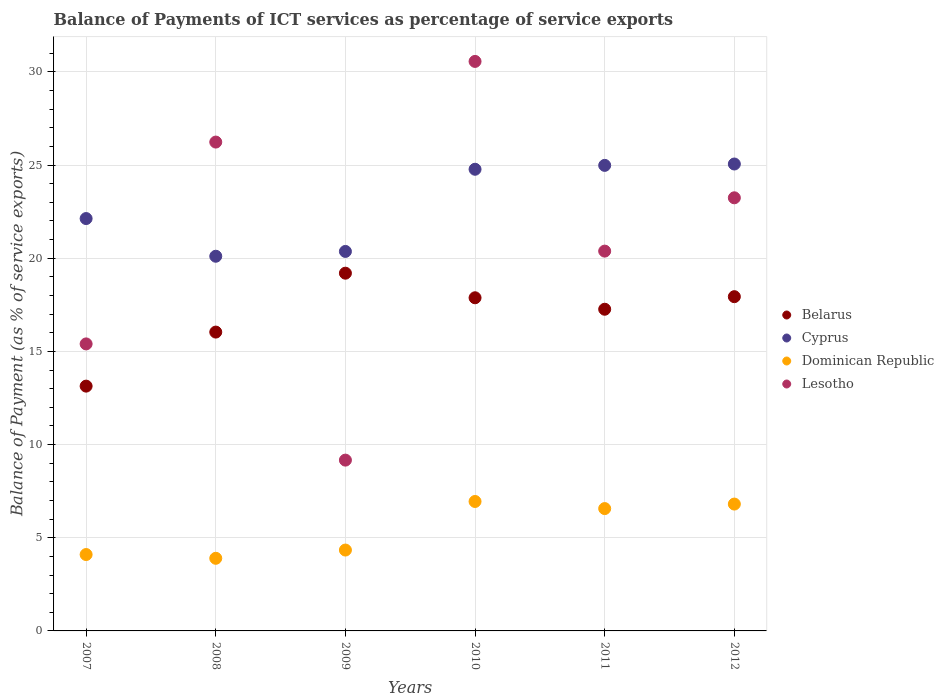How many different coloured dotlines are there?
Your answer should be compact. 4. Is the number of dotlines equal to the number of legend labels?
Offer a very short reply. Yes. What is the balance of payments of ICT services in Belarus in 2007?
Provide a succinct answer. 13.14. Across all years, what is the maximum balance of payments of ICT services in Lesotho?
Make the answer very short. 30.56. Across all years, what is the minimum balance of payments of ICT services in Cyprus?
Your response must be concise. 20.11. In which year was the balance of payments of ICT services in Lesotho maximum?
Offer a terse response. 2010. What is the total balance of payments of ICT services in Dominican Republic in the graph?
Keep it short and to the point. 32.66. What is the difference between the balance of payments of ICT services in Belarus in 2009 and that in 2010?
Keep it short and to the point. 1.32. What is the difference between the balance of payments of ICT services in Cyprus in 2007 and the balance of payments of ICT services in Dominican Republic in 2012?
Give a very brief answer. 15.32. What is the average balance of payments of ICT services in Belarus per year?
Give a very brief answer. 16.91. In the year 2010, what is the difference between the balance of payments of ICT services in Belarus and balance of payments of ICT services in Cyprus?
Ensure brevity in your answer.  -6.9. In how many years, is the balance of payments of ICT services in Lesotho greater than 7 %?
Your answer should be very brief. 6. What is the ratio of the balance of payments of ICT services in Belarus in 2010 to that in 2012?
Give a very brief answer. 1. Is the balance of payments of ICT services in Belarus in 2007 less than that in 2010?
Your response must be concise. Yes. What is the difference between the highest and the second highest balance of payments of ICT services in Cyprus?
Provide a short and direct response. 0.07. What is the difference between the highest and the lowest balance of payments of ICT services in Belarus?
Ensure brevity in your answer.  6.06. In how many years, is the balance of payments of ICT services in Lesotho greater than the average balance of payments of ICT services in Lesotho taken over all years?
Your response must be concise. 3. Is it the case that in every year, the sum of the balance of payments of ICT services in Belarus and balance of payments of ICT services in Cyprus  is greater than the sum of balance of payments of ICT services in Dominican Republic and balance of payments of ICT services in Lesotho?
Offer a very short reply. No. Does the balance of payments of ICT services in Cyprus monotonically increase over the years?
Give a very brief answer. No. How many years are there in the graph?
Your response must be concise. 6. Does the graph contain grids?
Provide a short and direct response. Yes. What is the title of the graph?
Keep it short and to the point. Balance of Payments of ICT services as percentage of service exports. What is the label or title of the Y-axis?
Your response must be concise. Balance of Payment (as % of service exports). What is the Balance of Payment (as % of service exports) in Belarus in 2007?
Make the answer very short. 13.14. What is the Balance of Payment (as % of service exports) of Cyprus in 2007?
Make the answer very short. 22.13. What is the Balance of Payment (as % of service exports) of Dominican Republic in 2007?
Give a very brief answer. 4.1. What is the Balance of Payment (as % of service exports) in Lesotho in 2007?
Offer a very short reply. 15.4. What is the Balance of Payment (as % of service exports) of Belarus in 2008?
Your answer should be very brief. 16.04. What is the Balance of Payment (as % of service exports) of Cyprus in 2008?
Keep it short and to the point. 20.11. What is the Balance of Payment (as % of service exports) in Dominican Republic in 2008?
Offer a terse response. 3.9. What is the Balance of Payment (as % of service exports) in Lesotho in 2008?
Your answer should be very brief. 26.24. What is the Balance of Payment (as % of service exports) in Belarus in 2009?
Your answer should be compact. 19.2. What is the Balance of Payment (as % of service exports) of Cyprus in 2009?
Offer a very short reply. 20.37. What is the Balance of Payment (as % of service exports) in Dominican Republic in 2009?
Give a very brief answer. 4.34. What is the Balance of Payment (as % of service exports) in Lesotho in 2009?
Offer a very short reply. 9.17. What is the Balance of Payment (as % of service exports) in Belarus in 2010?
Your answer should be compact. 17.88. What is the Balance of Payment (as % of service exports) in Cyprus in 2010?
Keep it short and to the point. 24.78. What is the Balance of Payment (as % of service exports) in Dominican Republic in 2010?
Offer a very short reply. 6.95. What is the Balance of Payment (as % of service exports) of Lesotho in 2010?
Your answer should be very brief. 30.56. What is the Balance of Payment (as % of service exports) in Belarus in 2011?
Offer a very short reply. 17.26. What is the Balance of Payment (as % of service exports) of Cyprus in 2011?
Your answer should be very brief. 24.98. What is the Balance of Payment (as % of service exports) in Dominican Republic in 2011?
Make the answer very short. 6.57. What is the Balance of Payment (as % of service exports) of Lesotho in 2011?
Give a very brief answer. 20.38. What is the Balance of Payment (as % of service exports) of Belarus in 2012?
Provide a short and direct response. 17.94. What is the Balance of Payment (as % of service exports) in Cyprus in 2012?
Offer a terse response. 25.06. What is the Balance of Payment (as % of service exports) of Dominican Republic in 2012?
Your answer should be very brief. 6.81. What is the Balance of Payment (as % of service exports) of Lesotho in 2012?
Ensure brevity in your answer.  23.24. Across all years, what is the maximum Balance of Payment (as % of service exports) in Belarus?
Your answer should be very brief. 19.2. Across all years, what is the maximum Balance of Payment (as % of service exports) in Cyprus?
Give a very brief answer. 25.06. Across all years, what is the maximum Balance of Payment (as % of service exports) of Dominican Republic?
Offer a very short reply. 6.95. Across all years, what is the maximum Balance of Payment (as % of service exports) in Lesotho?
Make the answer very short. 30.56. Across all years, what is the minimum Balance of Payment (as % of service exports) of Belarus?
Your response must be concise. 13.14. Across all years, what is the minimum Balance of Payment (as % of service exports) in Cyprus?
Keep it short and to the point. 20.11. Across all years, what is the minimum Balance of Payment (as % of service exports) in Dominican Republic?
Your response must be concise. 3.9. Across all years, what is the minimum Balance of Payment (as % of service exports) of Lesotho?
Keep it short and to the point. 9.17. What is the total Balance of Payment (as % of service exports) in Belarus in the graph?
Keep it short and to the point. 101.45. What is the total Balance of Payment (as % of service exports) in Cyprus in the graph?
Make the answer very short. 137.42. What is the total Balance of Payment (as % of service exports) in Dominican Republic in the graph?
Your answer should be compact. 32.66. What is the total Balance of Payment (as % of service exports) of Lesotho in the graph?
Make the answer very short. 124.99. What is the difference between the Balance of Payment (as % of service exports) in Belarus in 2007 and that in 2008?
Your response must be concise. -2.9. What is the difference between the Balance of Payment (as % of service exports) in Cyprus in 2007 and that in 2008?
Ensure brevity in your answer.  2.02. What is the difference between the Balance of Payment (as % of service exports) of Dominican Republic in 2007 and that in 2008?
Give a very brief answer. 0.2. What is the difference between the Balance of Payment (as % of service exports) of Lesotho in 2007 and that in 2008?
Your answer should be compact. -10.83. What is the difference between the Balance of Payment (as % of service exports) in Belarus in 2007 and that in 2009?
Provide a succinct answer. -6.06. What is the difference between the Balance of Payment (as % of service exports) of Cyprus in 2007 and that in 2009?
Offer a terse response. 1.76. What is the difference between the Balance of Payment (as % of service exports) of Dominican Republic in 2007 and that in 2009?
Keep it short and to the point. -0.24. What is the difference between the Balance of Payment (as % of service exports) of Lesotho in 2007 and that in 2009?
Provide a short and direct response. 6.24. What is the difference between the Balance of Payment (as % of service exports) of Belarus in 2007 and that in 2010?
Give a very brief answer. -4.74. What is the difference between the Balance of Payment (as % of service exports) of Cyprus in 2007 and that in 2010?
Provide a succinct answer. -2.65. What is the difference between the Balance of Payment (as % of service exports) of Dominican Republic in 2007 and that in 2010?
Ensure brevity in your answer.  -2.85. What is the difference between the Balance of Payment (as % of service exports) in Lesotho in 2007 and that in 2010?
Ensure brevity in your answer.  -15.16. What is the difference between the Balance of Payment (as % of service exports) in Belarus in 2007 and that in 2011?
Give a very brief answer. -4.13. What is the difference between the Balance of Payment (as % of service exports) of Cyprus in 2007 and that in 2011?
Give a very brief answer. -2.85. What is the difference between the Balance of Payment (as % of service exports) in Dominican Republic in 2007 and that in 2011?
Offer a terse response. -2.47. What is the difference between the Balance of Payment (as % of service exports) of Lesotho in 2007 and that in 2011?
Your response must be concise. -4.98. What is the difference between the Balance of Payment (as % of service exports) of Belarus in 2007 and that in 2012?
Ensure brevity in your answer.  -4.8. What is the difference between the Balance of Payment (as % of service exports) of Cyprus in 2007 and that in 2012?
Your response must be concise. -2.93. What is the difference between the Balance of Payment (as % of service exports) of Dominican Republic in 2007 and that in 2012?
Offer a very short reply. -2.71. What is the difference between the Balance of Payment (as % of service exports) in Lesotho in 2007 and that in 2012?
Your response must be concise. -7.84. What is the difference between the Balance of Payment (as % of service exports) in Belarus in 2008 and that in 2009?
Give a very brief answer. -3.16. What is the difference between the Balance of Payment (as % of service exports) of Cyprus in 2008 and that in 2009?
Your answer should be compact. -0.26. What is the difference between the Balance of Payment (as % of service exports) in Dominican Republic in 2008 and that in 2009?
Make the answer very short. -0.44. What is the difference between the Balance of Payment (as % of service exports) of Lesotho in 2008 and that in 2009?
Provide a short and direct response. 17.07. What is the difference between the Balance of Payment (as % of service exports) in Belarus in 2008 and that in 2010?
Provide a succinct answer. -1.84. What is the difference between the Balance of Payment (as % of service exports) in Cyprus in 2008 and that in 2010?
Your answer should be very brief. -4.67. What is the difference between the Balance of Payment (as % of service exports) of Dominican Republic in 2008 and that in 2010?
Give a very brief answer. -3.05. What is the difference between the Balance of Payment (as % of service exports) of Lesotho in 2008 and that in 2010?
Ensure brevity in your answer.  -4.33. What is the difference between the Balance of Payment (as % of service exports) in Belarus in 2008 and that in 2011?
Provide a short and direct response. -1.23. What is the difference between the Balance of Payment (as % of service exports) of Cyprus in 2008 and that in 2011?
Your answer should be compact. -4.88. What is the difference between the Balance of Payment (as % of service exports) in Dominican Republic in 2008 and that in 2011?
Offer a very short reply. -2.67. What is the difference between the Balance of Payment (as % of service exports) of Lesotho in 2008 and that in 2011?
Keep it short and to the point. 5.85. What is the difference between the Balance of Payment (as % of service exports) of Belarus in 2008 and that in 2012?
Make the answer very short. -1.9. What is the difference between the Balance of Payment (as % of service exports) in Cyprus in 2008 and that in 2012?
Make the answer very short. -4.95. What is the difference between the Balance of Payment (as % of service exports) of Dominican Republic in 2008 and that in 2012?
Provide a succinct answer. -2.91. What is the difference between the Balance of Payment (as % of service exports) of Lesotho in 2008 and that in 2012?
Offer a terse response. 2.99. What is the difference between the Balance of Payment (as % of service exports) in Belarus in 2009 and that in 2010?
Keep it short and to the point. 1.32. What is the difference between the Balance of Payment (as % of service exports) of Cyprus in 2009 and that in 2010?
Offer a very short reply. -4.41. What is the difference between the Balance of Payment (as % of service exports) of Dominican Republic in 2009 and that in 2010?
Offer a terse response. -2.61. What is the difference between the Balance of Payment (as % of service exports) of Lesotho in 2009 and that in 2010?
Make the answer very short. -21.4. What is the difference between the Balance of Payment (as % of service exports) in Belarus in 2009 and that in 2011?
Offer a terse response. 1.93. What is the difference between the Balance of Payment (as % of service exports) in Cyprus in 2009 and that in 2011?
Offer a very short reply. -4.62. What is the difference between the Balance of Payment (as % of service exports) of Dominican Republic in 2009 and that in 2011?
Keep it short and to the point. -2.23. What is the difference between the Balance of Payment (as % of service exports) of Lesotho in 2009 and that in 2011?
Offer a terse response. -11.22. What is the difference between the Balance of Payment (as % of service exports) of Belarus in 2009 and that in 2012?
Ensure brevity in your answer.  1.26. What is the difference between the Balance of Payment (as % of service exports) in Cyprus in 2009 and that in 2012?
Make the answer very short. -4.69. What is the difference between the Balance of Payment (as % of service exports) in Dominican Republic in 2009 and that in 2012?
Ensure brevity in your answer.  -2.47. What is the difference between the Balance of Payment (as % of service exports) of Lesotho in 2009 and that in 2012?
Offer a terse response. -14.08. What is the difference between the Balance of Payment (as % of service exports) in Belarus in 2010 and that in 2011?
Provide a short and direct response. 0.62. What is the difference between the Balance of Payment (as % of service exports) in Cyprus in 2010 and that in 2011?
Your answer should be compact. -0.21. What is the difference between the Balance of Payment (as % of service exports) of Dominican Republic in 2010 and that in 2011?
Make the answer very short. 0.38. What is the difference between the Balance of Payment (as % of service exports) in Lesotho in 2010 and that in 2011?
Your answer should be very brief. 10.18. What is the difference between the Balance of Payment (as % of service exports) in Belarus in 2010 and that in 2012?
Your response must be concise. -0.06. What is the difference between the Balance of Payment (as % of service exports) of Cyprus in 2010 and that in 2012?
Keep it short and to the point. -0.28. What is the difference between the Balance of Payment (as % of service exports) in Dominican Republic in 2010 and that in 2012?
Your response must be concise. 0.14. What is the difference between the Balance of Payment (as % of service exports) in Lesotho in 2010 and that in 2012?
Offer a terse response. 7.32. What is the difference between the Balance of Payment (as % of service exports) of Belarus in 2011 and that in 2012?
Your answer should be very brief. -0.67. What is the difference between the Balance of Payment (as % of service exports) of Cyprus in 2011 and that in 2012?
Your response must be concise. -0.07. What is the difference between the Balance of Payment (as % of service exports) of Dominican Republic in 2011 and that in 2012?
Your answer should be compact. -0.24. What is the difference between the Balance of Payment (as % of service exports) in Lesotho in 2011 and that in 2012?
Ensure brevity in your answer.  -2.86. What is the difference between the Balance of Payment (as % of service exports) of Belarus in 2007 and the Balance of Payment (as % of service exports) of Cyprus in 2008?
Keep it short and to the point. -6.97. What is the difference between the Balance of Payment (as % of service exports) of Belarus in 2007 and the Balance of Payment (as % of service exports) of Dominican Republic in 2008?
Offer a terse response. 9.24. What is the difference between the Balance of Payment (as % of service exports) in Belarus in 2007 and the Balance of Payment (as % of service exports) in Lesotho in 2008?
Ensure brevity in your answer.  -13.1. What is the difference between the Balance of Payment (as % of service exports) of Cyprus in 2007 and the Balance of Payment (as % of service exports) of Dominican Republic in 2008?
Provide a short and direct response. 18.23. What is the difference between the Balance of Payment (as % of service exports) of Cyprus in 2007 and the Balance of Payment (as % of service exports) of Lesotho in 2008?
Give a very brief answer. -4.1. What is the difference between the Balance of Payment (as % of service exports) of Dominican Republic in 2007 and the Balance of Payment (as % of service exports) of Lesotho in 2008?
Keep it short and to the point. -22.14. What is the difference between the Balance of Payment (as % of service exports) of Belarus in 2007 and the Balance of Payment (as % of service exports) of Cyprus in 2009?
Provide a succinct answer. -7.23. What is the difference between the Balance of Payment (as % of service exports) in Belarus in 2007 and the Balance of Payment (as % of service exports) in Dominican Republic in 2009?
Give a very brief answer. 8.8. What is the difference between the Balance of Payment (as % of service exports) of Belarus in 2007 and the Balance of Payment (as % of service exports) of Lesotho in 2009?
Provide a short and direct response. 3.97. What is the difference between the Balance of Payment (as % of service exports) in Cyprus in 2007 and the Balance of Payment (as % of service exports) in Dominican Republic in 2009?
Your answer should be very brief. 17.79. What is the difference between the Balance of Payment (as % of service exports) in Cyprus in 2007 and the Balance of Payment (as % of service exports) in Lesotho in 2009?
Make the answer very short. 12.96. What is the difference between the Balance of Payment (as % of service exports) in Dominican Republic in 2007 and the Balance of Payment (as % of service exports) in Lesotho in 2009?
Ensure brevity in your answer.  -5.07. What is the difference between the Balance of Payment (as % of service exports) in Belarus in 2007 and the Balance of Payment (as % of service exports) in Cyprus in 2010?
Your response must be concise. -11.64. What is the difference between the Balance of Payment (as % of service exports) in Belarus in 2007 and the Balance of Payment (as % of service exports) in Dominican Republic in 2010?
Your response must be concise. 6.19. What is the difference between the Balance of Payment (as % of service exports) of Belarus in 2007 and the Balance of Payment (as % of service exports) of Lesotho in 2010?
Keep it short and to the point. -17.43. What is the difference between the Balance of Payment (as % of service exports) in Cyprus in 2007 and the Balance of Payment (as % of service exports) in Dominican Republic in 2010?
Your answer should be very brief. 15.18. What is the difference between the Balance of Payment (as % of service exports) in Cyprus in 2007 and the Balance of Payment (as % of service exports) in Lesotho in 2010?
Provide a succinct answer. -8.43. What is the difference between the Balance of Payment (as % of service exports) of Dominican Republic in 2007 and the Balance of Payment (as % of service exports) of Lesotho in 2010?
Give a very brief answer. -26.46. What is the difference between the Balance of Payment (as % of service exports) in Belarus in 2007 and the Balance of Payment (as % of service exports) in Cyprus in 2011?
Your answer should be very brief. -11.85. What is the difference between the Balance of Payment (as % of service exports) of Belarus in 2007 and the Balance of Payment (as % of service exports) of Dominican Republic in 2011?
Your answer should be compact. 6.57. What is the difference between the Balance of Payment (as % of service exports) of Belarus in 2007 and the Balance of Payment (as % of service exports) of Lesotho in 2011?
Your answer should be compact. -7.25. What is the difference between the Balance of Payment (as % of service exports) of Cyprus in 2007 and the Balance of Payment (as % of service exports) of Dominican Republic in 2011?
Ensure brevity in your answer.  15.56. What is the difference between the Balance of Payment (as % of service exports) of Cyprus in 2007 and the Balance of Payment (as % of service exports) of Lesotho in 2011?
Offer a terse response. 1.75. What is the difference between the Balance of Payment (as % of service exports) of Dominican Republic in 2007 and the Balance of Payment (as % of service exports) of Lesotho in 2011?
Your answer should be very brief. -16.28. What is the difference between the Balance of Payment (as % of service exports) of Belarus in 2007 and the Balance of Payment (as % of service exports) of Cyprus in 2012?
Your response must be concise. -11.92. What is the difference between the Balance of Payment (as % of service exports) in Belarus in 2007 and the Balance of Payment (as % of service exports) in Dominican Republic in 2012?
Your answer should be compact. 6.33. What is the difference between the Balance of Payment (as % of service exports) in Belarus in 2007 and the Balance of Payment (as % of service exports) in Lesotho in 2012?
Offer a terse response. -10.11. What is the difference between the Balance of Payment (as % of service exports) in Cyprus in 2007 and the Balance of Payment (as % of service exports) in Dominican Republic in 2012?
Provide a short and direct response. 15.32. What is the difference between the Balance of Payment (as % of service exports) of Cyprus in 2007 and the Balance of Payment (as % of service exports) of Lesotho in 2012?
Your response must be concise. -1.11. What is the difference between the Balance of Payment (as % of service exports) in Dominican Republic in 2007 and the Balance of Payment (as % of service exports) in Lesotho in 2012?
Your response must be concise. -19.14. What is the difference between the Balance of Payment (as % of service exports) in Belarus in 2008 and the Balance of Payment (as % of service exports) in Cyprus in 2009?
Your answer should be compact. -4.33. What is the difference between the Balance of Payment (as % of service exports) of Belarus in 2008 and the Balance of Payment (as % of service exports) of Dominican Republic in 2009?
Offer a terse response. 11.7. What is the difference between the Balance of Payment (as % of service exports) of Belarus in 2008 and the Balance of Payment (as % of service exports) of Lesotho in 2009?
Make the answer very short. 6.87. What is the difference between the Balance of Payment (as % of service exports) of Cyprus in 2008 and the Balance of Payment (as % of service exports) of Dominican Republic in 2009?
Your answer should be compact. 15.77. What is the difference between the Balance of Payment (as % of service exports) in Cyprus in 2008 and the Balance of Payment (as % of service exports) in Lesotho in 2009?
Your answer should be very brief. 10.94. What is the difference between the Balance of Payment (as % of service exports) in Dominican Republic in 2008 and the Balance of Payment (as % of service exports) in Lesotho in 2009?
Make the answer very short. -5.27. What is the difference between the Balance of Payment (as % of service exports) in Belarus in 2008 and the Balance of Payment (as % of service exports) in Cyprus in 2010?
Give a very brief answer. -8.74. What is the difference between the Balance of Payment (as % of service exports) in Belarus in 2008 and the Balance of Payment (as % of service exports) in Dominican Republic in 2010?
Offer a very short reply. 9.09. What is the difference between the Balance of Payment (as % of service exports) of Belarus in 2008 and the Balance of Payment (as % of service exports) of Lesotho in 2010?
Your answer should be very brief. -14.53. What is the difference between the Balance of Payment (as % of service exports) in Cyprus in 2008 and the Balance of Payment (as % of service exports) in Dominican Republic in 2010?
Your answer should be very brief. 13.16. What is the difference between the Balance of Payment (as % of service exports) in Cyprus in 2008 and the Balance of Payment (as % of service exports) in Lesotho in 2010?
Offer a very short reply. -10.46. What is the difference between the Balance of Payment (as % of service exports) in Dominican Republic in 2008 and the Balance of Payment (as % of service exports) in Lesotho in 2010?
Your answer should be very brief. -26.67. What is the difference between the Balance of Payment (as % of service exports) of Belarus in 2008 and the Balance of Payment (as % of service exports) of Cyprus in 2011?
Offer a terse response. -8.95. What is the difference between the Balance of Payment (as % of service exports) in Belarus in 2008 and the Balance of Payment (as % of service exports) in Dominican Republic in 2011?
Your answer should be compact. 9.47. What is the difference between the Balance of Payment (as % of service exports) in Belarus in 2008 and the Balance of Payment (as % of service exports) in Lesotho in 2011?
Your response must be concise. -4.35. What is the difference between the Balance of Payment (as % of service exports) in Cyprus in 2008 and the Balance of Payment (as % of service exports) in Dominican Republic in 2011?
Your response must be concise. 13.54. What is the difference between the Balance of Payment (as % of service exports) in Cyprus in 2008 and the Balance of Payment (as % of service exports) in Lesotho in 2011?
Your response must be concise. -0.28. What is the difference between the Balance of Payment (as % of service exports) of Dominican Republic in 2008 and the Balance of Payment (as % of service exports) of Lesotho in 2011?
Offer a terse response. -16.49. What is the difference between the Balance of Payment (as % of service exports) of Belarus in 2008 and the Balance of Payment (as % of service exports) of Cyprus in 2012?
Make the answer very short. -9.02. What is the difference between the Balance of Payment (as % of service exports) in Belarus in 2008 and the Balance of Payment (as % of service exports) in Dominican Republic in 2012?
Make the answer very short. 9.23. What is the difference between the Balance of Payment (as % of service exports) in Belarus in 2008 and the Balance of Payment (as % of service exports) in Lesotho in 2012?
Make the answer very short. -7.21. What is the difference between the Balance of Payment (as % of service exports) in Cyprus in 2008 and the Balance of Payment (as % of service exports) in Lesotho in 2012?
Keep it short and to the point. -3.14. What is the difference between the Balance of Payment (as % of service exports) in Dominican Republic in 2008 and the Balance of Payment (as % of service exports) in Lesotho in 2012?
Keep it short and to the point. -19.35. What is the difference between the Balance of Payment (as % of service exports) in Belarus in 2009 and the Balance of Payment (as % of service exports) in Cyprus in 2010?
Provide a short and direct response. -5.58. What is the difference between the Balance of Payment (as % of service exports) in Belarus in 2009 and the Balance of Payment (as % of service exports) in Dominican Republic in 2010?
Keep it short and to the point. 12.25. What is the difference between the Balance of Payment (as % of service exports) of Belarus in 2009 and the Balance of Payment (as % of service exports) of Lesotho in 2010?
Your response must be concise. -11.37. What is the difference between the Balance of Payment (as % of service exports) of Cyprus in 2009 and the Balance of Payment (as % of service exports) of Dominican Republic in 2010?
Provide a short and direct response. 13.42. What is the difference between the Balance of Payment (as % of service exports) of Cyprus in 2009 and the Balance of Payment (as % of service exports) of Lesotho in 2010?
Keep it short and to the point. -10.2. What is the difference between the Balance of Payment (as % of service exports) in Dominican Republic in 2009 and the Balance of Payment (as % of service exports) in Lesotho in 2010?
Ensure brevity in your answer.  -26.22. What is the difference between the Balance of Payment (as % of service exports) of Belarus in 2009 and the Balance of Payment (as % of service exports) of Cyprus in 2011?
Your answer should be very brief. -5.79. What is the difference between the Balance of Payment (as % of service exports) of Belarus in 2009 and the Balance of Payment (as % of service exports) of Dominican Republic in 2011?
Your answer should be very brief. 12.63. What is the difference between the Balance of Payment (as % of service exports) of Belarus in 2009 and the Balance of Payment (as % of service exports) of Lesotho in 2011?
Keep it short and to the point. -1.18. What is the difference between the Balance of Payment (as % of service exports) in Cyprus in 2009 and the Balance of Payment (as % of service exports) in Dominican Republic in 2011?
Give a very brief answer. 13.8. What is the difference between the Balance of Payment (as % of service exports) in Cyprus in 2009 and the Balance of Payment (as % of service exports) in Lesotho in 2011?
Your response must be concise. -0.02. What is the difference between the Balance of Payment (as % of service exports) in Dominican Republic in 2009 and the Balance of Payment (as % of service exports) in Lesotho in 2011?
Your answer should be compact. -16.04. What is the difference between the Balance of Payment (as % of service exports) of Belarus in 2009 and the Balance of Payment (as % of service exports) of Cyprus in 2012?
Keep it short and to the point. -5.86. What is the difference between the Balance of Payment (as % of service exports) in Belarus in 2009 and the Balance of Payment (as % of service exports) in Dominican Republic in 2012?
Make the answer very short. 12.39. What is the difference between the Balance of Payment (as % of service exports) of Belarus in 2009 and the Balance of Payment (as % of service exports) of Lesotho in 2012?
Your answer should be compact. -4.05. What is the difference between the Balance of Payment (as % of service exports) of Cyprus in 2009 and the Balance of Payment (as % of service exports) of Dominican Republic in 2012?
Your response must be concise. 13.56. What is the difference between the Balance of Payment (as % of service exports) of Cyprus in 2009 and the Balance of Payment (as % of service exports) of Lesotho in 2012?
Give a very brief answer. -2.88. What is the difference between the Balance of Payment (as % of service exports) in Dominican Republic in 2009 and the Balance of Payment (as % of service exports) in Lesotho in 2012?
Make the answer very short. -18.9. What is the difference between the Balance of Payment (as % of service exports) of Belarus in 2010 and the Balance of Payment (as % of service exports) of Cyprus in 2011?
Provide a succinct answer. -7.11. What is the difference between the Balance of Payment (as % of service exports) in Belarus in 2010 and the Balance of Payment (as % of service exports) in Dominican Republic in 2011?
Your answer should be compact. 11.31. What is the difference between the Balance of Payment (as % of service exports) of Belarus in 2010 and the Balance of Payment (as % of service exports) of Lesotho in 2011?
Provide a succinct answer. -2.5. What is the difference between the Balance of Payment (as % of service exports) in Cyprus in 2010 and the Balance of Payment (as % of service exports) in Dominican Republic in 2011?
Offer a terse response. 18.21. What is the difference between the Balance of Payment (as % of service exports) in Cyprus in 2010 and the Balance of Payment (as % of service exports) in Lesotho in 2011?
Keep it short and to the point. 4.39. What is the difference between the Balance of Payment (as % of service exports) in Dominican Republic in 2010 and the Balance of Payment (as % of service exports) in Lesotho in 2011?
Give a very brief answer. -13.44. What is the difference between the Balance of Payment (as % of service exports) in Belarus in 2010 and the Balance of Payment (as % of service exports) in Cyprus in 2012?
Your answer should be very brief. -7.18. What is the difference between the Balance of Payment (as % of service exports) of Belarus in 2010 and the Balance of Payment (as % of service exports) of Dominican Republic in 2012?
Keep it short and to the point. 11.07. What is the difference between the Balance of Payment (as % of service exports) of Belarus in 2010 and the Balance of Payment (as % of service exports) of Lesotho in 2012?
Offer a very short reply. -5.37. What is the difference between the Balance of Payment (as % of service exports) of Cyprus in 2010 and the Balance of Payment (as % of service exports) of Dominican Republic in 2012?
Provide a short and direct response. 17.97. What is the difference between the Balance of Payment (as % of service exports) of Cyprus in 2010 and the Balance of Payment (as % of service exports) of Lesotho in 2012?
Ensure brevity in your answer.  1.53. What is the difference between the Balance of Payment (as % of service exports) in Dominican Republic in 2010 and the Balance of Payment (as % of service exports) in Lesotho in 2012?
Give a very brief answer. -16.3. What is the difference between the Balance of Payment (as % of service exports) in Belarus in 2011 and the Balance of Payment (as % of service exports) in Cyprus in 2012?
Provide a succinct answer. -7.79. What is the difference between the Balance of Payment (as % of service exports) of Belarus in 2011 and the Balance of Payment (as % of service exports) of Dominican Republic in 2012?
Give a very brief answer. 10.46. What is the difference between the Balance of Payment (as % of service exports) in Belarus in 2011 and the Balance of Payment (as % of service exports) in Lesotho in 2012?
Offer a very short reply. -5.98. What is the difference between the Balance of Payment (as % of service exports) in Cyprus in 2011 and the Balance of Payment (as % of service exports) in Dominican Republic in 2012?
Make the answer very short. 18.18. What is the difference between the Balance of Payment (as % of service exports) of Cyprus in 2011 and the Balance of Payment (as % of service exports) of Lesotho in 2012?
Keep it short and to the point. 1.74. What is the difference between the Balance of Payment (as % of service exports) in Dominican Republic in 2011 and the Balance of Payment (as % of service exports) in Lesotho in 2012?
Provide a short and direct response. -16.68. What is the average Balance of Payment (as % of service exports) of Belarus per year?
Your response must be concise. 16.91. What is the average Balance of Payment (as % of service exports) in Cyprus per year?
Give a very brief answer. 22.9. What is the average Balance of Payment (as % of service exports) of Dominican Republic per year?
Your answer should be compact. 5.44. What is the average Balance of Payment (as % of service exports) of Lesotho per year?
Keep it short and to the point. 20.83. In the year 2007, what is the difference between the Balance of Payment (as % of service exports) in Belarus and Balance of Payment (as % of service exports) in Cyprus?
Offer a terse response. -8.99. In the year 2007, what is the difference between the Balance of Payment (as % of service exports) of Belarus and Balance of Payment (as % of service exports) of Dominican Republic?
Provide a succinct answer. 9.04. In the year 2007, what is the difference between the Balance of Payment (as % of service exports) in Belarus and Balance of Payment (as % of service exports) in Lesotho?
Offer a very short reply. -2.27. In the year 2007, what is the difference between the Balance of Payment (as % of service exports) in Cyprus and Balance of Payment (as % of service exports) in Dominican Republic?
Give a very brief answer. 18.03. In the year 2007, what is the difference between the Balance of Payment (as % of service exports) of Cyprus and Balance of Payment (as % of service exports) of Lesotho?
Provide a succinct answer. 6.73. In the year 2007, what is the difference between the Balance of Payment (as % of service exports) of Dominican Republic and Balance of Payment (as % of service exports) of Lesotho?
Offer a terse response. -11.3. In the year 2008, what is the difference between the Balance of Payment (as % of service exports) in Belarus and Balance of Payment (as % of service exports) in Cyprus?
Provide a succinct answer. -4.07. In the year 2008, what is the difference between the Balance of Payment (as % of service exports) in Belarus and Balance of Payment (as % of service exports) in Dominican Republic?
Ensure brevity in your answer.  12.14. In the year 2008, what is the difference between the Balance of Payment (as % of service exports) of Belarus and Balance of Payment (as % of service exports) of Lesotho?
Your answer should be very brief. -10.2. In the year 2008, what is the difference between the Balance of Payment (as % of service exports) of Cyprus and Balance of Payment (as % of service exports) of Dominican Republic?
Your answer should be very brief. 16.21. In the year 2008, what is the difference between the Balance of Payment (as % of service exports) in Cyprus and Balance of Payment (as % of service exports) in Lesotho?
Offer a terse response. -6.13. In the year 2008, what is the difference between the Balance of Payment (as % of service exports) in Dominican Republic and Balance of Payment (as % of service exports) in Lesotho?
Offer a terse response. -22.34. In the year 2009, what is the difference between the Balance of Payment (as % of service exports) in Belarus and Balance of Payment (as % of service exports) in Cyprus?
Ensure brevity in your answer.  -1.17. In the year 2009, what is the difference between the Balance of Payment (as % of service exports) in Belarus and Balance of Payment (as % of service exports) in Dominican Republic?
Make the answer very short. 14.86. In the year 2009, what is the difference between the Balance of Payment (as % of service exports) in Belarus and Balance of Payment (as % of service exports) in Lesotho?
Provide a short and direct response. 10.03. In the year 2009, what is the difference between the Balance of Payment (as % of service exports) of Cyprus and Balance of Payment (as % of service exports) of Dominican Republic?
Offer a very short reply. 16.03. In the year 2009, what is the difference between the Balance of Payment (as % of service exports) of Cyprus and Balance of Payment (as % of service exports) of Lesotho?
Make the answer very short. 11.2. In the year 2009, what is the difference between the Balance of Payment (as % of service exports) of Dominican Republic and Balance of Payment (as % of service exports) of Lesotho?
Offer a very short reply. -4.83. In the year 2010, what is the difference between the Balance of Payment (as % of service exports) of Belarus and Balance of Payment (as % of service exports) of Cyprus?
Keep it short and to the point. -6.9. In the year 2010, what is the difference between the Balance of Payment (as % of service exports) in Belarus and Balance of Payment (as % of service exports) in Dominican Republic?
Your response must be concise. 10.93. In the year 2010, what is the difference between the Balance of Payment (as % of service exports) in Belarus and Balance of Payment (as % of service exports) in Lesotho?
Your answer should be very brief. -12.68. In the year 2010, what is the difference between the Balance of Payment (as % of service exports) in Cyprus and Balance of Payment (as % of service exports) in Dominican Republic?
Provide a succinct answer. 17.83. In the year 2010, what is the difference between the Balance of Payment (as % of service exports) of Cyprus and Balance of Payment (as % of service exports) of Lesotho?
Give a very brief answer. -5.79. In the year 2010, what is the difference between the Balance of Payment (as % of service exports) in Dominican Republic and Balance of Payment (as % of service exports) in Lesotho?
Your answer should be very brief. -23.62. In the year 2011, what is the difference between the Balance of Payment (as % of service exports) of Belarus and Balance of Payment (as % of service exports) of Cyprus?
Offer a terse response. -7.72. In the year 2011, what is the difference between the Balance of Payment (as % of service exports) of Belarus and Balance of Payment (as % of service exports) of Dominican Republic?
Make the answer very short. 10.7. In the year 2011, what is the difference between the Balance of Payment (as % of service exports) of Belarus and Balance of Payment (as % of service exports) of Lesotho?
Offer a terse response. -3.12. In the year 2011, what is the difference between the Balance of Payment (as % of service exports) of Cyprus and Balance of Payment (as % of service exports) of Dominican Republic?
Offer a terse response. 18.42. In the year 2011, what is the difference between the Balance of Payment (as % of service exports) in Cyprus and Balance of Payment (as % of service exports) in Lesotho?
Offer a terse response. 4.6. In the year 2011, what is the difference between the Balance of Payment (as % of service exports) in Dominican Republic and Balance of Payment (as % of service exports) in Lesotho?
Offer a very short reply. -13.82. In the year 2012, what is the difference between the Balance of Payment (as % of service exports) in Belarus and Balance of Payment (as % of service exports) in Cyprus?
Your response must be concise. -7.12. In the year 2012, what is the difference between the Balance of Payment (as % of service exports) of Belarus and Balance of Payment (as % of service exports) of Dominican Republic?
Offer a terse response. 11.13. In the year 2012, what is the difference between the Balance of Payment (as % of service exports) of Belarus and Balance of Payment (as % of service exports) of Lesotho?
Offer a very short reply. -5.31. In the year 2012, what is the difference between the Balance of Payment (as % of service exports) in Cyprus and Balance of Payment (as % of service exports) in Dominican Republic?
Make the answer very short. 18.25. In the year 2012, what is the difference between the Balance of Payment (as % of service exports) in Cyprus and Balance of Payment (as % of service exports) in Lesotho?
Provide a short and direct response. 1.81. In the year 2012, what is the difference between the Balance of Payment (as % of service exports) of Dominican Republic and Balance of Payment (as % of service exports) of Lesotho?
Your answer should be compact. -16.44. What is the ratio of the Balance of Payment (as % of service exports) of Belarus in 2007 to that in 2008?
Ensure brevity in your answer.  0.82. What is the ratio of the Balance of Payment (as % of service exports) of Cyprus in 2007 to that in 2008?
Your answer should be very brief. 1.1. What is the ratio of the Balance of Payment (as % of service exports) in Dominican Republic in 2007 to that in 2008?
Keep it short and to the point. 1.05. What is the ratio of the Balance of Payment (as % of service exports) of Lesotho in 2007 to that in 2008?
Offer a terse response. 0.59. What is the ratio of the Balance of Payment (as % of service exports) of Belarus in 2007 to that in 2009?
Offer a terse response. 0.68. What is the ratio of the Balance of Payment (as % of service exports) of Cyprus in 2007 to that in 2009?
Provide a succinct answer. 1.09. What is the ratio of the Balance of Payment (as % of service exports) of Dominican Republic in 2007 to that in 2009?
Your answer should be compact. 0.94. What is the ratio of the Balance of Payment (as % of service exports) in Lesotho in 2007 to that in 2009?
Your answer should be compact. 1.68. What is the ratio of the Balance of Payment (as % of service exports) of Belarus in 2007 to that in 2010?
Give a very brief answer. 0.73. What is the ratio of the Balance of Payment (as % of service exports) of Cyprus in 2007 to that in 2010?
Ensure brevity in your answer.  0.89. What is the ratio of the Balance of Payment (as % of service exports) of Dominican Republic in 2007 to that in 2010?
Make the answer very short. 0.59. What is the ratio of the Balance of Payment (as % of service exports) in Lesotho in 2007 to that in 2010?
Keep it short and to the point. 0.5. What is the ratio of the Balance of Payment (as % of service exports) of Belarus in 2007 to that in 2011?
Your answer should be compact. 0.76. What is the ratio of the Balance of Payment (as % of service exports) in Cyprus in 2007 to that in 2011?
Provide a short and direct response. 0.89. What is the ratio of the Balance of Payment (as % of service exports) in Dominican Republic in 2007 to that in 2011?
Your answer should be very brief. 0.62. What is the ratio of the Balance of Payment (as % of service exports) of Lesotho in 2007 to that in 2011?
Provide a short and direct response. 0.76. What is the ratio of the Balance of Payment (as % of service exports) of Belarus in 2007 to that in 2012?
Offer a terse response. 0.73. What is the ratio of the Balance of Payment (as % of service exports) in Cyprus in 2007 to that in 2012?
Provide a short and direct response. 0.88. What is the ratio of the Balance of Payment (as % of service exports) of Dominican Republic in 2007 to that in 2012?
Keep it short and to the point. 0.6. What is the ratio of the Balance of Payment (as % of service exports) of Lesotho in 2007 to that in 2012?
Offer a very short reply. 0.66. What is the ratio of the Balance of Payment (as % of service exports) in Belarus in 2008 to that in 2009?
Offer a very short reply. 0.84. What is the ratio of the Balance of Payment (as % of service exports) in Cyprus in 2008 to that in 2009?
Ensure brevity in your answer.  0.99. What is the ratio of the Balance of Payment (as % of service exports) in Dominican Republic in 2008 to that in 2009?
Keep it short and to the point. 0.9. What is the ratio of the Balance of Payment (as % of service exports) in Lesotho in 2008 to that in 2009?
Offer a very short reply. 2.86. What is the ratio of the Balance of Payment (as % of service exports) in Belarus in 2008 to that in 2010?
Provide a succinct answer. 0.9. What is the ratio of the Balance of Payment (as % of service exports) of Cyprus in 2008 to that in 2010?
Your answer should be compact. 0.81. What is the ratio of the Balance of Payment (as % of service exports) in Dominican Republic in 2008 to that in 2010?
Offer a very short reply. 0.56. What is the ratio of the Balance of Payment (as % of service exports) in Lesotho in 2008 to that in 2010?
Make the answer very short. 0.86. What is the ratio of the Balance of Payment (as % of service exports) in Belarus in 2008 to that in 2011?
Your answer should be compact. 0.93. What is the ratio of the Balance of Payment (as % of service exports) in Cyprus in 2008 to that in 2011?
Provide a succinct answer. 0.8. What is the ratio of the Balance of Payment (as % of service exports) in Dominican Republic in 2008 to that in 2011?
Offer a very short reply. 0.59. What is the ratio of the Balance of Payment (as % of service exports) in Lesotho in 2008 to that in 2011?
Provide a short and direct response. 1.29. What is the ratio of the Balance of Payment (as % of service exports) of Belarus in 2008 to that in 2012?
Your answer should be very brief. 0.89. What is the ratio of the Balance of Payment (as % of service exports) of Cyprus in 2008 to that in 2012?
Give a very brief answer. 0.8. What is the ratio of the Balance of Payment (as % of service exports) in Dominican Republic in 2008 to that in 2012?
Your answer should be compact. 0.57. What is the ratio of the Balance of Payment (as % of service exports) in Lesotho in 2008 to that in 2012?
Keep it short and to the point. 1.13. What is the ratio of the Balance of Payment (as % of service exports) of Belarus in 2009 to that in 2010?
Give a very brief answer. 1.07. What is the ratio of the Balance of Payment (as % of service exports) in Cyprus in 2009 to that in 2010?
Give a very brief answer. 0.82. What is the ratio of the Balance of Payment (as % of service exports) of Dominican Republic in 2009 to that in 2010?
Provide a short and direct response. 0.62. What is the ratio of the Balance of Payment (as % of service exports) in Lesotho in 2009 to that in 2010?
Make the answer very short. 0.3. What is the ratio of the Balance of Payment (as % of service exports) of Belarus in 2009 to that in 2011?
Give a very brief answer. 1.11. What is the ratio of the Balance of Payment (as % of service exports) in Cyprus in 2009 to that in 2011?
Give a very brief answer. 0.82. What is the ratio of the Balance of Payment (as % of service exports) of Dominican Republic in 2009 to that in 2011?
Ensure brevity in your answer.  0.66. What is the ratio of the Balance of Payment (as % of service exports) in Lesotho in 2009 to that in 2011?
Give a very brief answer. 0.45. What is the ratio of the Balance of Payment (as % of service exports) of Belarus in 2009 to that in 2012?
Give a very brief answer. 1.07. What is the ratio of the Balance of Payment (as % of service exports) in Cyprus in 2009 to that in 2012?
Provide a succinct answer. 0.81. What is the ratio of the Balance of Payment (as % of service exports) of Dominican Republic in 2009 to that in 2012?
Keep it short and to the point. 0.64. What is the ratio of the Balance of Payment (as % of service exports) of Lesotho in 2009 to that in 2012?
Keep it short and to the point. 0.39. What is the ratio of the Balance of Payment (as % of service exports) of Belarus in 2010 to that in 2011?
Provide a succinct answer. 1.04. What is the ratio of the Balance of Payment (as % of service exports) in Cyprus in 2010 to that in 2011?
Make the answer very short. 0.99. What is the ratio of the Balance of Payment (as % of service exports) in Dominican Republic in 2010 to that in 2011?
Your answer should be compact. 1.06. What is the ratio of the Balance of Payment (as % of service exports) in Lesotho in 2010 to that in 2011?
Give a very brief answer. 1.5. What is the ratio of the Balance of Payment (as % of service exports) of Belarus in 2010 to that in 2012?
Keep it short and to the point. 1. What is the ratio of the Balance of Payment (as % of service exports) in Dominican Republic in 2010 to that in 2012?
Provide a succinct answer. 1.02. What is the ratio of the Balance of Payment (as % of service exports) in Lesotho in 2010 to that in 2012?
Offer a very short reply. 1.31. What is the ratio of the Balance of Payment (as % of service exports) of Belarus in 2011 to that in 2012?
Provide a succinct answer. 0.96. What is the ratio of the Balance of Payment (as % of service exports) of Cyprus in 2011 to that in 2012?
Provide a short and direct response. 1. What is the ratio of the Balance of Payment (as % of service exports) of Dominican Republic in 2011 to that in 2012?
Provide a short and direct response. 0.96. What is the ratio of the Balance of Payment (as % of service exports) in Lesotho in 2011 to that in 2012?
Provide a short and direct response. 0.88. What is the difference between the highest and the second highest Balance of Payment (as % of service exports) in Belarus?
Provide a succinct answer. 1.26. What is the difference between the highest and the second highest Balance of Payment (as % of service exports) of Cyprus?
Provide a short and direct response. 0.07. What is the difference between the highest and the second highest Balance of Payment (as % of service exports) in Dominican Republic?
Make the answer very short. 0.14. What is the difference between the highest and the second highest Balance of Payment (as % of service exports) in Lesotho?
Ensure brevity in your answer.  4.33. What is the difference between the highest and the lowest Balance of Payment (as % of service exports) in Belarus?
Your answer should be very brief. 6.06. What is the difference between the highest and the lowest Balance of Payment (as % of service exports) in Cyprus?
Make the answer very short. 4.95. What is the difference between the highest and the lowest Balance of Payment (as % of service exports) in Dominican Republic?
Your answer should be very brief. 3.05. What is the difference between the highest and the lowest Balance of Payment (as % of service exports) of Lesotho?
Your response must be concise. 21.4. 